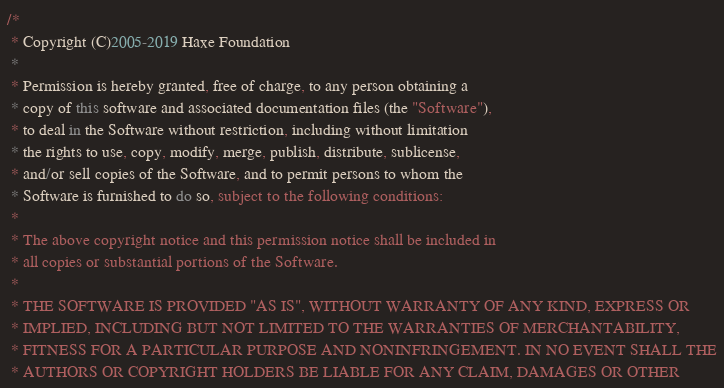Convert code to text. <code><loc_0><loc_0><loc_500><loc_500><_Haxe_>/*
 * Copyright (C)2005-2019 Haxe Foundation
 *
 * Permission is hereby granted, free of charge, to any person obtaining a
 * copy of this software and associated documentation files (the "Software"),
 * to deal in the Software without restriction, including without limitation
 * the rights to use, copy, modify, merge, publish, distribute, sublicense,
 * and/or sell copies of the Software, and to permit persons to whom the
 * Software is furnished to do so, subject to the following conditions:
 *
 * The above copyright notice and this permission notice shall be included in
 * all copies or substantial portions of the Software.
 *
 * THE SOFTWARE IS PROVIDED "AS IS", WITHOUT WARRANTY OF ANY KIND, EXPRESS OR
 * IMPLIED, INCLUDING BUT NOT LIMITED TO THE WARRANTIES OF MERCHANTABILITY,
 * FITNESS FOR A PARTICULAR PURPOSE AND NONINFRINGEMENT. IN NO EVENT SHALL THE
 * AUTHORS OR COPYRIGHT HOLDERS BE LIABLE FOR ANY CLAIM, DAMAGES OR OTHER</code> 